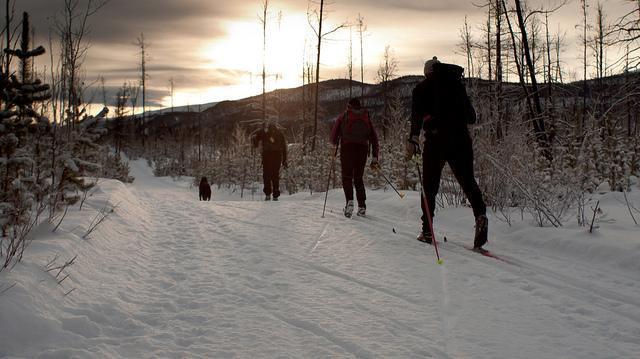How many people are walking?
Give a very brief answer. 4. How many people can you see?
Give a very brief answer. 2. How many chair legs are touching only the orange surface of the floor?
Give a very brief answer. 0. 